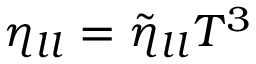Convert formula to latex. <formula><loc_0><loc_0><loc_500><loc_500>\eta _ { l l } = \tilde { \eta } _ { l l } T ^ { 3 }</formula> 